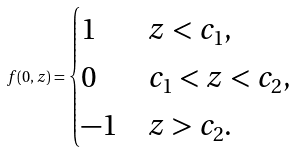<formula> <loc_0><loc_0><loc_500><loc_500>f ( 0 , z ) = \begin{cases} 1 & z < c _ { 1 } , \\ 0 & c _ { 1 } < z < c _ { 2 } , \\ - 1 & z > c _ { 2 } . \\ \end{cases}</formula> 